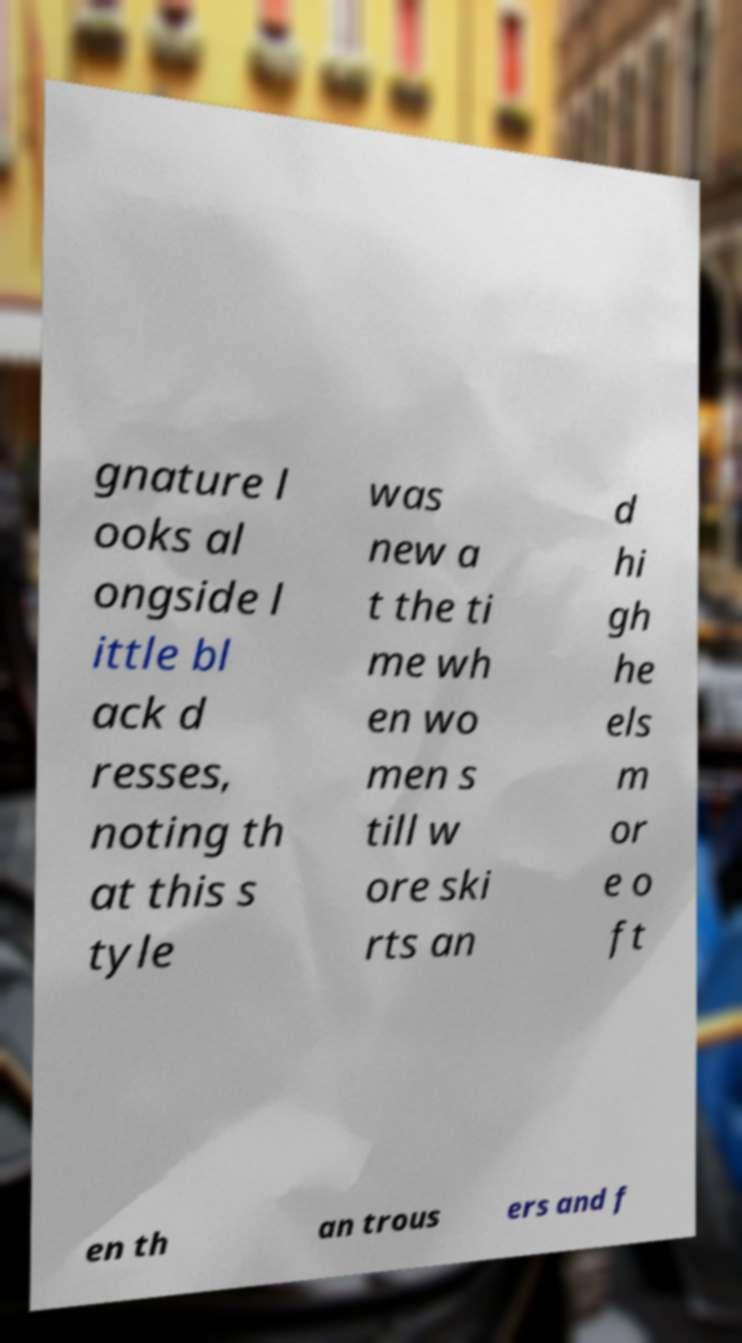Please read and relay the text visible in this image. What does it say? gnature l ooks al ongside l ittle bl ack d resses, noting th at this s tyle was new a t the ti me wh en wo men s till w ore ski rts an d hi gh he els m or e o ft en th an trous ers and f 